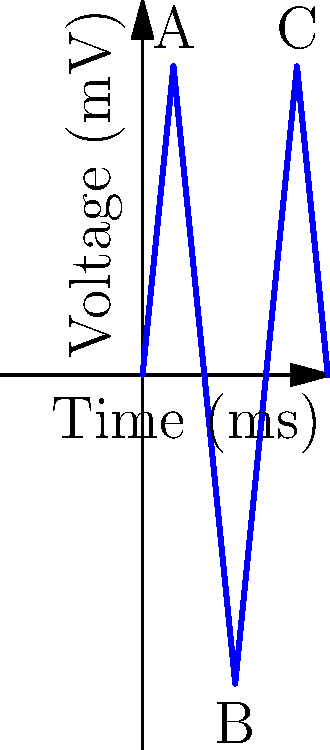The voltage-time plot above represents an electrical stimulation protocol applied to a conductive biomaterial seeded with stem cells. Based on the waveform, which of the following statements is most likely true regarding stem cell behavior?

A) The stem cells will primarily differentiate into osteoblasts
B) The stem cells will primarily differentiate into cardiomyocytes
C) The stem cells will primarily differentiate into neurons
D) The stem cells will remain undifferentiated To answer this question, we need to analyze the voltage-time plot and understand how different electrical stimulation patterns affect stem cell behavior:

1. Waveform analysis:
   - The plot shows a biphasic waveform with alternating positive and negative voltage pulses.
   - The pulse duration is approximately 5 ms for each phase.
   - The peak-to-peak voltage is 100 mV (from +50 mV to -50 mV).
   - The frequency of the waveform is about 33 Hz (one complete cycle every 30 ms).

2. Effect of electrical stimulation on stem cells:
   - Different cell types respond to specific electrical stimulation patterns.
   - Neurons typically respond to rapid, short-duration pulses with frequencies in the range of 10-100 Hz.
   - Cardiomyocytes usually require lower frequencies (1-3 Hz) to mimic natural heart rhythms.
   - Osteoblasts generally respond to lower frequencies (≤ 15 Hz) and longer pulse durations.

3. Matching the waveform to cell type:
   - The observed waveform has characteristics most similar to those used for neuronal stimulation:
     a) Short pulse duration (5 ms)
     b) Biphasic pulses (alternating positive and negative)
     c) Frequency within the range for neuronal stimulation (33 Hz)

4. Ruling out other options:
   - The frequency is too high for cardiomyocyte differentiation.
   - The pulse duration is too short for osteoblast differentiation.
   - The strong, regular stimulation pattern is unlikely to maintain stem cells in an undifferentiated state.

Based on this analysis, the electrical stimulation protocol is most likely to promote neuronal differentiation in the stem cells.
Answer: C) The stem cells will primarily differentiate into neurons 